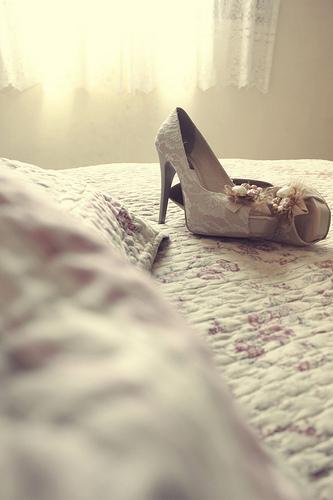How many shoes are on the bed?
Give a very brief answer. 2. 